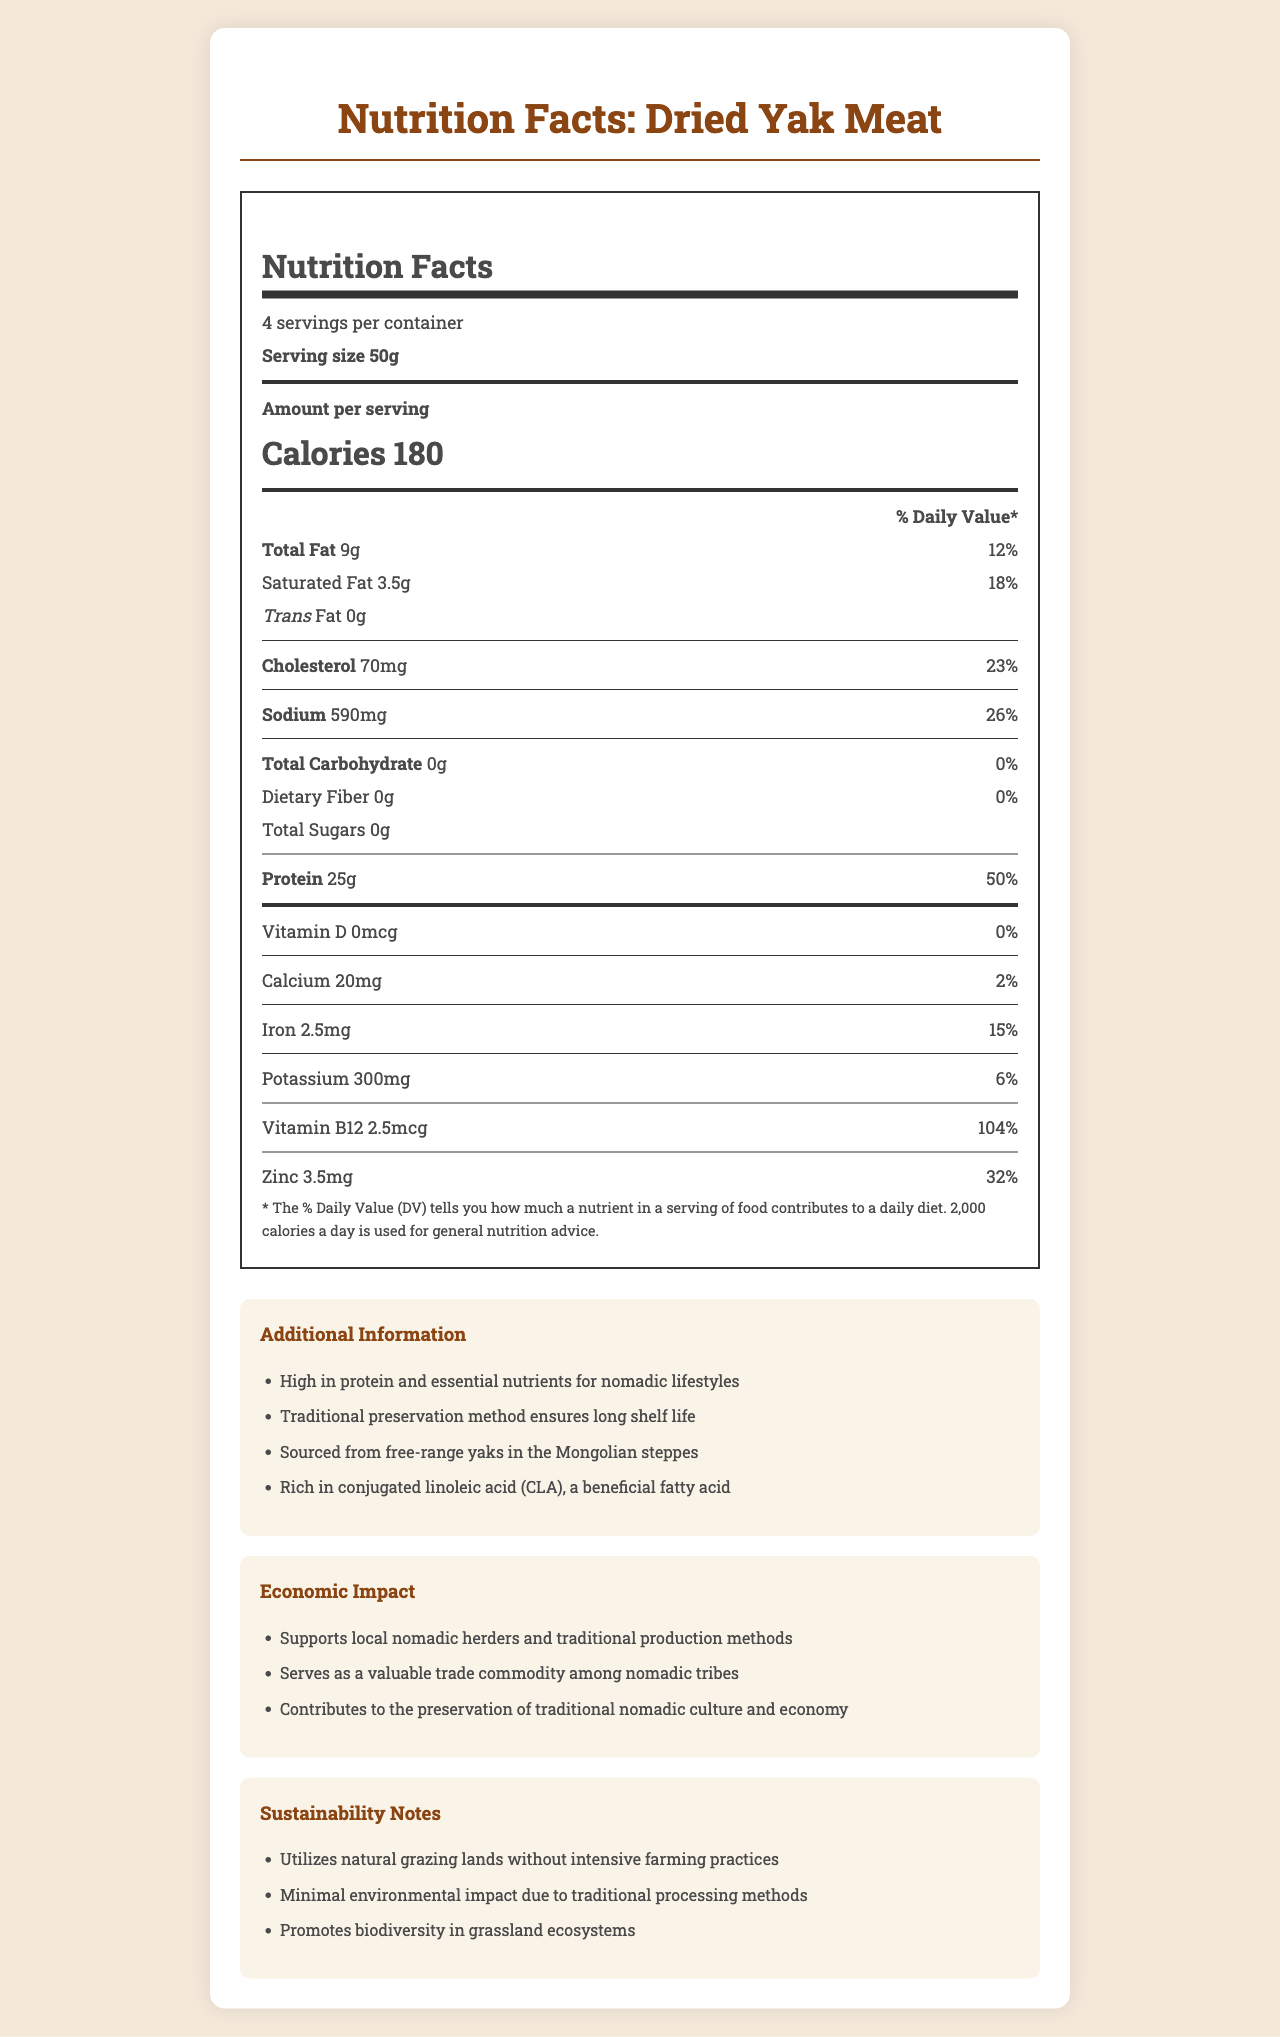What is the serving size for Dried Yak Meat? The document specifies a serving size of 50g for Dried Yak Meat.
Answer: 50g How many calories are in one serving of Dried Yak Meat? The document states that there are 180 calories in one serving of Dried Yak Meat.
Answer: 180 calories What is the total fat content per serving of Dried Yak Meat? The document lists the total fat per serving as 9g.
Answer: 9g How much protein does one serving of Dried Yak Meat provide? The document specifies that one serving of Dried Yak Meat provides 25g of protein.
Answer: 25g What percentage of the daily value of zinc does each serving contain? The document states that each serving contains 32% of the daily value of zinc.
Answer: 32% Which nutrient is not present in Dried Yak Meat? A. Carbohydrates B. Protein C. Sodium D. Iron The document shows that the total carbohydrate content is 0g per serving.
Answer: A. Carbohydrates What is the primary preservation method for Dried Yak Meat? A. Salting B. Smoking C. Drying D. Freezing The document mentions "Traditional preservation method ensures long shelf life," which implies drying.
Answer: C. Drying Is there any trans fat in Dried Yak Meat? The document states that the trans fat content is 0g.
Answer: No Summarize the main idea of the document. The document outlines the nutrition facts of Dried Yak Meat, emphasizing its high protein and valuable nutrient content, and explains its benefits for nomads, impact on local economy, and sustainable production methods.
Answer: The document provides detailed nutritional information about Dried Yak Meat, highlighting its high protein and moderate fat content. It discusses serving size, daily value percentages for various nutrients, additional benefits, economic impact, and sustainability notes concerning the traditional nomadic practices. What is the cholesterol content per serving, and what percentage of the daily value does it constitute? The document indicates that one serving contains 70mg of cholesterol, which is 23% of the daily value.
Answer: 70mg, 23% What traditional lifestyle does Dried Yak Meat support? The document notes "High in protein and essential nutrients for nomadic lifestyles" and mentions its significance for nomadic tribes.
Answer: Nomadic lifestyle How much calcium is present in one serving, and what is the daily value percentage? The document specifies that one serving contains 20mg of calcium, which is 2% of the daily value.
Answer: 20mg, 2% What beneficial fatty acid is mentioned in the document? The document describes Dried Yak Meat as being "Rich in conjugated linoleic acid (CLA), a beneficial fatty acid."
Answer: Conjugated linoleic acid (CLA) Does the document mention the environmental impact of Dried Yak Meat production methods? The document includes a section on sustainability notes that mentions the minimal environmental impact and promotion of biodiversity due to traditional processing methods.
Answer: Yes Can the exact price of Dried Yak Meat be determined from the document? The document does not include any information about the price of Dried Yak Meat.
Answer: No 